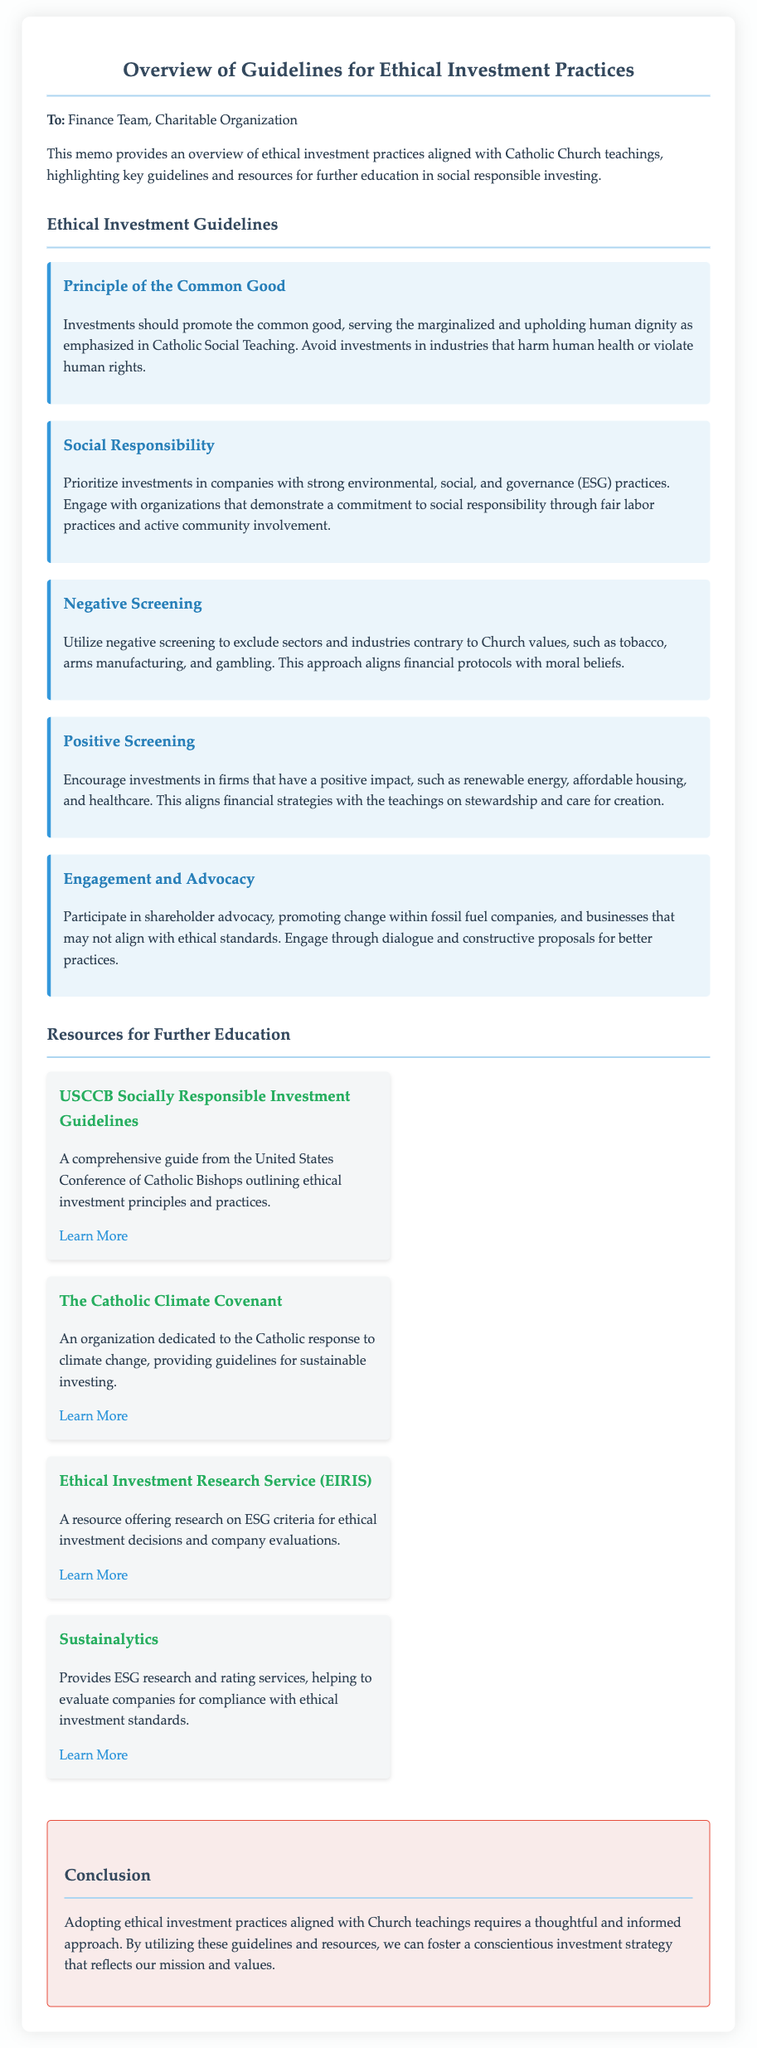What is the title of the memo? The title of the memo is provided at the beginning of the document.
Answer: Overview of Guidelines for Ethical Investment Practices Who is the memo addressed to? The memo specifies the recipient in the opening paragraph.
Answer: Finance Team, Charitable Organization What is one principle of ethical investment mentioned in the document? The document lists several principles under the guidelines section.
Answer: Principle of the Common Good What does "negative screening" refer to in the context of the memo? The document defines negative screening as the exclusion of certain sectors contrary to Church values.
Answer: Exclude sectors and industries contrary to Church values Name one organization mentioned in the resources for further education. The memo lists resources that offer additional information on ethical investing practices.
Answer: USCCB Socially Responsible Investment Guidelines How many guidelines for ethical investment are outlined in the document? The document provides a specific count of guidelines in the guidelines section.
Answer: Five What does the memo suggest regarding shareholder advocacy? The memo highlights a particular activity regarding engagement and advocacy.
Answer: Promote change within fossil fuel companies Where can one find the Ethical Investment Research Service (EIRIS)? The resource section lists where to find EIRIS in the document.
Answer: https://www.eiris.org 